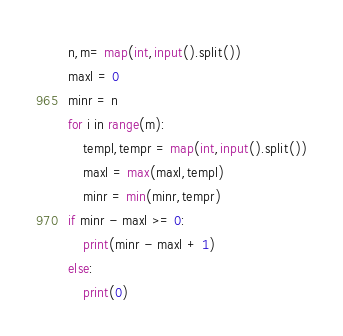Convert code to text. <code><loc_0><loc_0><loc_500><loc_500><_Python_>n,m= map(int,input().split())
maxl = 0
minr = n
for i in range(m):
    templ,tempr = map(int,input().split())
    maxl = max(maxl,templ)
    minr = min(minr,tempr)
if minr - maxl >= 0:
    print(minr - maxl + 1)
else:
    print(0)
</code> 